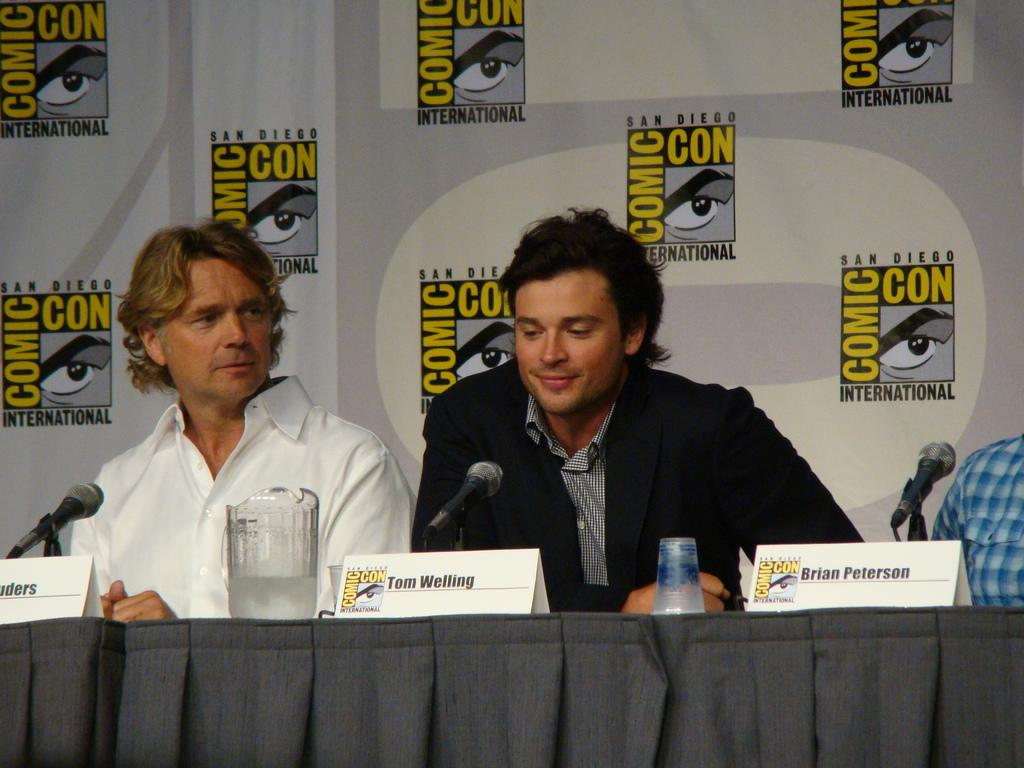How many people are sitting in the image? There are three persons sitting in the image. What can be seen on the table in the image? There is a jug, a glass, and miles (possibly miles markers or a scale) on the table. What is the purpose of the name plates in the image? The name plates in the image may be used to identify the persons sitting. What is the background of the image? There is a board in the background of the image. What type of jeans are the persons wearing in the image? There is no information about the type of jeans the persons are wearing in the image, as the focus is on the sitting arrangement and other objects on the table. 